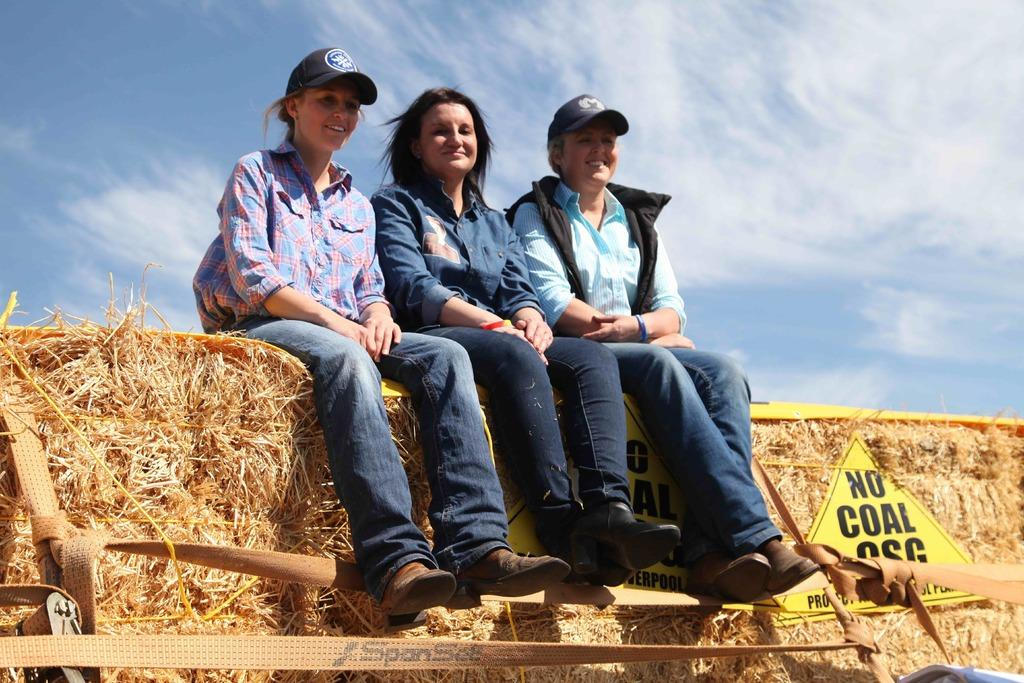How many people are in the image? There are three persons in the image. What are the persons doing in the image? The persons are sitting on a grassy wall. Where is the grassy wall located in the image? The grassy wall is in the middle of the image. What can be seen in the background of the image? There is a sky visible in the background of the image. What letter is being balanced on the grassy wall in the image? There is no letter present in the image, and therefore no such activity can be observed. 